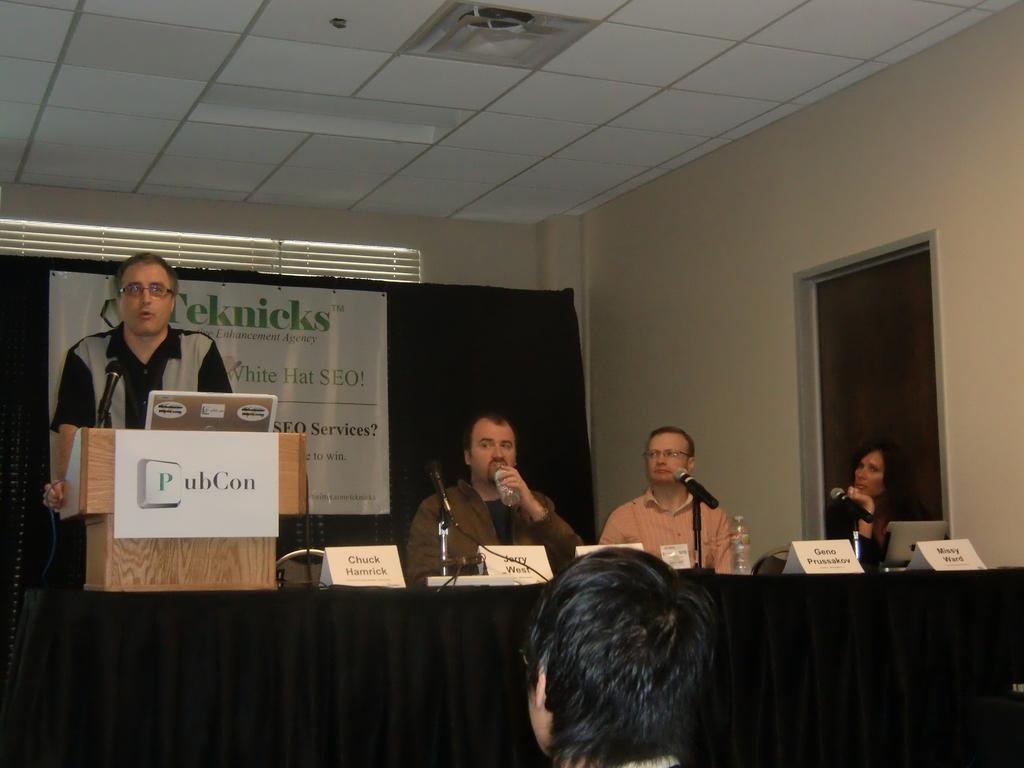Can you describe this image briefly? In this image there are three man and one women,two man and one women are sitting and the man standing here in front of the man there is a podium and a micro phone. At the back ground there is a banner and a wall,in front of the man there is a person sitting. 